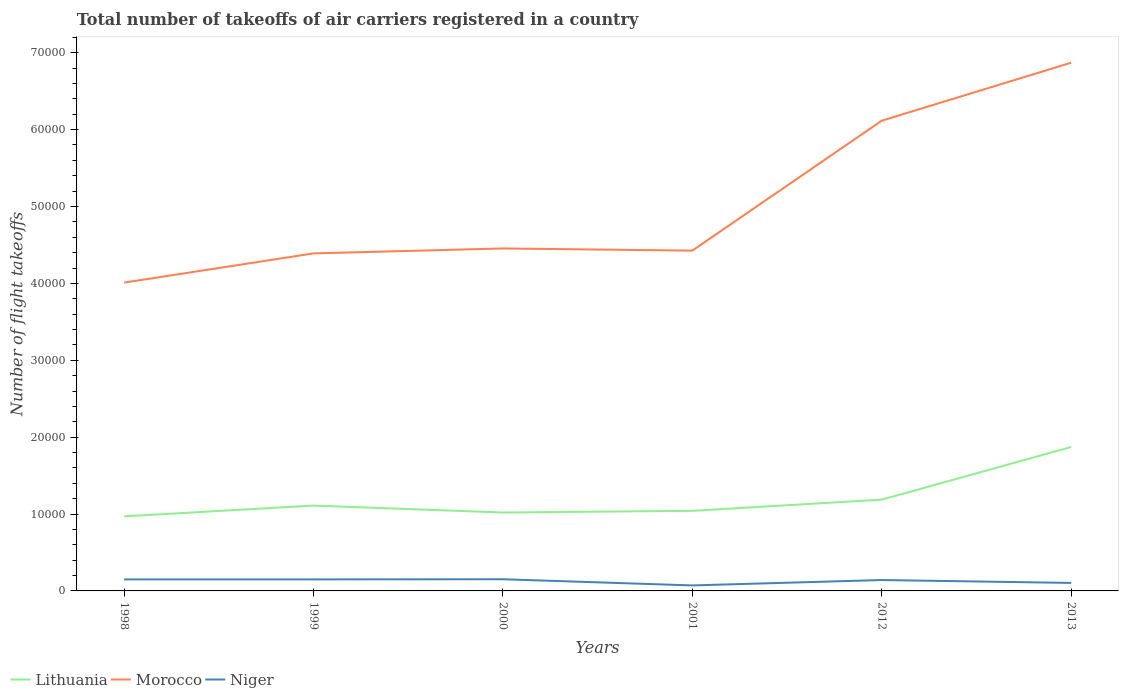How many different coloured lines are there?
Ensure brevity in your answer.  3. Does the line corresponding to Lithuania intersect with the line corresponding to Niger?
Provide a short and direct response. No. Is the number of lines equal to the number of legend labels?
Your answer should be very brief. Yes. Across all years, what is the maximum total number of flight takeoffs in Morocco?
Offer a very short reply. 4.01e+04. What is the total total number of flight takeoffs in Lithuania in the graph?
Ensure brevity in your answer.  -6846.54. What is the difference between the highest and the second highest total number of flight takeoffs in Niger?
Ensure brevity in your answer.  802. How many lines are there?
Keep it short and to the point. 3. How many years are there in the graph?
Your answer should be very brief. 6. Does the graph contain any zero values?
Ensure brevity in your answer.  No. Does the graph contain grids?
Make the answer very short. No. Where does the legend appear in the graph?
Your answer should be compact. Bottom left. How many legend labels are there?
Ensure brevity in your answer.  3. What is the title of the graph?
Make the answer very short. Total number of takeoffs of air carriers registered in a country. Does "Sweden" appear as one of the legend labels in the graph?
Ensure brevity in your answer.  No. What is the label or title of the Y-axis?
Keep it short and to the point. Number of flight takeoffs. What is the Number of flight takeoffs of Lithuania in 1998?
Your answer should be very brief. 9700. What is the Number of flight takeoffs in Morocco in 1998?
Your answer should be very brief. 4.01e+04. What is the Number of flight takeoffs in Niger in 1998?
Make the answer very short. 1500. What is the Number of flight takeoffs in Lithuania in 1999?
Offer a very short reply. 1.11e+04. What is the Number of flight takeoffs of Morocco in 1999?
Your response must be concise. 4.39e+04. What is the Number of flight takeoffs of Niger in 1999?
Keep it short and to the point. 1500. What is the Number of flight takeoffs of Lithuania in 2000?
Keep it short and to the point. 1.02e+04. What is the Number of flight takeoffs in Morocco in 2000?
Your answer should be very brief. 4.45e+04. What is the Number of flight takeoffs in Niger in 2000?
Provide a short and direct response. 1518. What is the Number of flight takeoffs of Lithuania in 2001?
Provide a succinct answer. 1.04e+04. What is the Number of flight takeoffs of Morocco in 2001?
Ensure brevity in your answer.  4.43e+04. What is the Number of flight takeoffs of Niger in 2001?
Provide a succinct answer. 716. What is the Number of flight takeoffs in Lithuania in 2012?
Your response must be concise. 1.19e+04. What is the Number of flight takeoffs in Morocco in 2012?
Ensure brevity in your answer.  6.12e+04. What is the Number of flight takeoffs in Niger in 2012?
Keep it short and to the point. 1416. What is the Number of flight takeoffs of Lithuania in 2013?
Ensure brevity in your answer.  1.87e+04. What is the Number of flight takeoffs of Morocco in 2013?
Your answer should be compact. 6.87e+04. What is the Number of flight takeoffs of Niger in 2013?
Give a very brief answer. 1040. Across all years, what is the maximum Number of flight takeoffs of Lithuania?
Offer a very short reply. 1.87e+04. Across all years, what is the maximum Number of flight takeoffs in Morocco?
Provide a succinct answer. 6.87e+04. Across all years, what is the maximum Number of flight takeoffs in Niger?
Give a very brief answer. 1518. Across all years, what is the minimum Number of flight takeoffs in Lithuania?
Offer a very short reply. 9700. Across all years, what is the minimum Number of flight takeoffs in Morocco?
Give a very brief answer. 4.01e+04. Across all years, what is the minimum Number of flight takeoffs of Niger?
Your answer should be very brief. 716. What is the total Number of flight takeoffs of Lithuania in the graph?
Your answer should be very brief. 7.20e+04. What is the total Number of flight takeoffs in Morocco in the graph?
Offer a terse response. 3.03e+05. What is the total Number of flight takeoffs in Niger in the graph?
Your response must be concise. 7690. What is the difference between the Number of flight takeoffs in Lithuania in 1998 and that in 1999?
Make the answer very short. -1400. What is the difference between the Number of flight takeoffs in Morocco in 1998 and that in 1999?
Your answer should be compact. -3800. What is the difference between the Number of flight takeoffs of Niger in 1998 and that in 1999?
Keep it short and to the point. 0. What is the difference between the Number of flight takeoffs in Lithuania in 1998 and that in 2000?
Give a very brief answer. -497. What is the difference between the Number of flight takeoffs in Morocco in 1998 and that in 2000?
Give a very brief answer. -4442. What is the difference between the Number of flight takeoffs in Lithuania in 1998 and that in 2001?
Offer a very short reply. -718. What is the difference between the Number of flight takeoffs in Morocco in 1998 and that in 2001?
Provide a short and direct response. -4162. What is the difference between the Number of flight takeoffs in Niger in 1998 and that in 2001?
Make the answer very short. 784. What is the difference between the Number of flight takeoffs in Lithuania in 1998 and that in 2012?
Provide a short and direct response. -2174. What is the difference between the Number of flight takeoffs in Morocco in 1998 and that in 2012?
Make the answer very short. -2.11e+04. What is the difference between the Number of flight takeoffs of Lithuania in 1998 and that in 2013?
Provide a succinct answer. -9020.54. What is the difference between the Number of flight takeoffs of Morocco in 1998 and that in 2013?
Offer a very short reply. -2.86e+04. What is the difference between the Number of flight takeoffs of Niger in 1998 and that in 2013?
Your response must be concise. 460. What is the difference between the Number of flight takeoffs of Lithuania in 1999 and that in 2000?
Ensure brevity in your answer.  903. What is the difference between the Number of flight takeoffs of Morocco in 1999 and that in 2000?
Ensure brevity in your answer.  -642. What is the difference between the Number of flight takeoffs of Niger in 1999 and that in 2000?
Your answer should be very brief. -18. What is the difference between the Number of flight takeoffs of Lithuania in 1999 and that in 2001?
Provide a succinct answer. 682. What is the difference between the Number of flight takeoffs of Morocco in 1999 and that in 2001?
Offer a very short reply. -362. What is the difference between the Number of flight takeoffs in Niger in 1999 and that in 2001?
Your answer should be very brief. 784. What is the difference between the Number of flight takeoffs in Lithuania in 1999 and that in 2012?
Provide a short and direct response. -774. What is the difference between the Number of flight takeoffs of Morocco in 1999 and that in 2012?
Offer a terse response. -1.73e+04. What is the difference between the Number of flight takeoffs in Lithuania in 1999 and that in 2013?
Your answer should be very brief. -7620.54. What is the difference between the Number of flight takeoffs in Morocco in 1999 and that in 2013?
Keep it short and to the point. -2.48e+04. What is the difference between the Number of flight takeoffs in Niger in 1999 and that in 2013?
Offer a terse response. 460. What is the difference between the Number of flight takeoffs in Lithuania in 2000 and that in 2001?
Offer a terse response. -221. What is the difference between the Number of flight takeoffs in Morocco in 2000 and that in 2001?
Provide a succinct answer. 280. What is the difference between the Number of flight takeoffs in Niger in 2000 and that in 2001?
Ensure brevity in your answer.  802. What is the difference between the Number of flight takeoffs of Lithuania in 2000 and that in 2012?
Offer a very short reply. -1677. What is the difference between the Number of flight takeoffs in Morocco in 2000 and that in 2012?
Offer a terse response. -1.66e+04. What is the difference between the Number of flight takeoffs of Niger in 2000 and that in 2012?
Provide a short and direct response. 102. What is the difference between the Number of flight takeoffs in Lithuania in 2000 and that in 2013?
Ensure brevity in your answer.  -8523.54. What is the difference between the Number of flight takeoffs of Morocco in 2000 and that in 2013?
Make the answer very short. -2.42e+04. What is the difference between the Number of flight takeoffs of Niger in 2000 and that in 2013?
Keep it short and to the point. 478. What is the difference between the Number of flight takeoffs in Lithuania in 2001 and that in 2012?
Ensure brevity in your answer.  -1456. What is the difference between the Number of flight takeoffs in Morocco in 2001 and that in 2012?
Offer a terse response. -1.69e+04. What is the difference between the Number of flight takeoffs in Niger in 2001 and that in 2012?
Keep it short and to the point. -700. What is the difference between the Number of flight takeoffs in Lithuania in 2001 and that in 2013?
Provide a short and direct response. -8302.54. What is the difference between the Number of flight takeoffs of Morocco in 2001 and that in 2013?
Give a very brief answer. -2.44e+04. What is the difference between the Number of flight takeoffs of Niger in 2001 and that in 2013?
Keep it short and to the point. -324. What is the difference between the Number of flight takeoffs in Lithuania in 2012 and that in 2013?
Your response must be concise. -6846.54. What is the difference between the Number of flight takeoffs in Morocco in 2012 and that in 2013?
Give a very brief answer. -7539.9. What is the difference between the Number of flight takeoffs of Niger in 2012 and that in 2013?
Provide a succinct answer. 376. What is the difference between the Number of flight takeoffs of Lithuania in 1998 and the Number of flight takeoffs of Morocco in 1999?
Keep it short and to the point. -3.42e+04. What is the difference between the Number of flight takeoffs of Lithuania in 1998 and the Number of flight takeoffs of Niger in 1999?
Offer a terse response. 8200. What is the difference between the Number of flight takeoffs in Morocco in 1998 and the Number of flight takeoffs in Niger in 1999?
Ensure brevity in your answer.  3.86e+04. What is the difference between the Number of flight takeoffs of Lithuania in 1998 and the Number of flight takeoffs of Morocco in 2000?
Make the answer very short. -3.48e+04. What is the difference between the Number of flight takeoffs in Lithuania in 1998 and the Number of flight takeoffs in Niger in 2000?
Keep it short and to the point. 8182. What is the difference between the Number of flight takeoffs in Morocco in 1998 and the Number of flight takeoffs in Niger in 2000?
Provide a short and direct response. 3.86e+04. What is the difference between the Number of flight takeoffs of Lithuania in 1998 and the Number of flight takeoffs of Morocco in 2001?
Give a very brief answer. -3.46e+04. What is the difference between the Number of flight takeoffs of Lithuania in 1998 and the Number of flight takeoffs of Niger in 2001?
Ensure brevity in your answer.  8984. What is the difference between the Number of flight takeoffs of Morocco in 1998 and the Number of flight takeoffs of Niger in 2001?
Ensure brevity in your answer.  3.94e+04. What is the difference between the Number of flight takeoffs in Lithuania in 1998 and the Number of flight takeoffs in Morocco in 2012?
Your response must be concise. -5.15e+04. What is the difference between the Number of flight takeoffs in Lithuania in 1998 and the Number of flight takeoffs in Niger in 2012?
Offer a terse response. 8284. What is the difference between the Number of flight takeoffs in Morocco in 1998 and the Number of flight takeoffs in Niger in 2012?
Your answer should be very brief. 3.87e+04. What is the difference between the Number of flight takeoffs of Lithuania in 1998 and the Number of flight takeoffs of Morocco in 2013?
Offer a terse response. -5.90e+04. What is the difference between the Number of flight takeoffs of Lithuania in 1998 and the Number of flight takeoffs of Niger in 2013?
Provide a succinct answer. 8660. What is the difference between the Number of flight takeoffs of Morocco in 1998 and the Number of flight takeoffs of Niger in 2013?
Provide a short and direct response. 3.91e+04. What is the difference between the Number of flight takeoffs of Lithuania in 1999 and the Number of flight takeoffs of Morocco in 2000?
Provide a succinct answer. -3.34e+04. What is the difference between the Number of flight takeoffs in Lithuania in 1999 and the Number of flight takeoffs in Niger in 2000?
Your answer should be compact. 9582. What is the difference between the Number of flight takeoffs of Morocco in 1999 and the Number of flight takeoffs of Niger in 2000?
Offer a terse response. 4.24e+04. What is the difference between the Number of flight takeoffs of Lithuania in 1999 and the Number of flight takeoffs of Morocco in 2001?
Provide a succinct answer. -3.32e+04. What is the difference between the Number of flight takeoffs in Lithuania in 1999 and the Number of flight takeoffs in Niger in 2001?
Your response must be concise. 1.04e+04. What is the difference between the Number of flight takeoffs of Morocco in 1999 and the Number of flight takeoffs of Niger in 2001?
Provide a succinct answer. 4.32e+04. What is the difference between the Number of flight takeoffs of Lithuania in 1999 and the Number of flight takeoffs of Morocco in 2012?
Ensure brevity in your answer.  -5.01e+04. What is the difference between the Number of flight takeoffs of Lithuania in 1999 and the Number of flight takeoffs of Niger in 2012?
Your answer should be very brief. 9684. What is the difference between the Number of flight takeoffs in Morocco in 1999 and the Number of flight takeoffs in Niger in 2012?
Keep it short and to the point. 4.25e+04. What is the difference between the Number of flight takeoffs of Lithuania in 1999 and the Number of flight takeoffs of Morocco in 2013?
Give a very brief answer. -5.76e+04. What is the difference between the Number of flight takeoffs in Lithuania in 1999 and the Number of flight takeoffs in Niger in 2013?
Provide a succinct answer. 1.01e+04. What is the difference between the Number of flight takeoffs in Morocco in 1999 and the Number of flight takeoffs in Niger in 2013?
Offer a terse response. 4.29e+04. What is the difference between the Number of flight takeoffs in Lithuania in 2000 and the Number of flight takeoffs in Morocco in 2001?
Your answer should be compact. -3.41e+04. What is the difference between the Number of flight takeoffs in Lithuania in 2000 and the Number of flight takeoffs in Niger in 2001?
Your answer should be compact. 9481. What is the difference between the Number of flight takeoffs of Morocco in 2000 and the Number of flight takeoffs of Niger in 2001?
Your answer should be very brief. 4.38e+04. What is the difference between the Number of flight takeoffs of Lithuania in 2000 and the Number of flight takeoffs of Morocco in 2012?
Provide a succinct answer. -5.10e+04. What is the difference between the Number of flight takeoffs in Lithuania in 2000 and the Number of flight takeoffs in Niger in 2012?
Make the answer very short. 8781. What is the difference between the Number of flight takeoffs of Morocco in 2000 and the Number of flight takeoffs of Niger in 2012?
Your response must be concise. 4.31e+04. What is the difference between the Number of flight takeoffs in Lithuania in 2000 and the Number of flight takeoffs in Morocco in 2013?
Provide a succinct answer. -5.85e+04. What is the difference between the Number of flight takeoffs of Lithuania in 2000 and the Number of flight takeoffs of Niger in 2013?
Keep it short and to the point. 9157. What is the difference between the Number of flight takeoffs of Morocco in 2000 and the Number of flight takeoffs of Niger in 2013?
Give a very brief answer. 4.35e+04. What is the difference between the Number of flight takeoffs in Lithuania in 2001 and the Number of flight takeoffs in Morocco in 2012?
Ensure brevity in your answer.  -5.07e+04. What is the difference between the Number of flight takeoffs in Lithuania in 2001 and the Number of flight takeoffs in Niger in 2012?
Make the answer very short. 9002. What is the difference between the Number of flight takeoffs of Morocco in 2001 and the Number of flight takeoffs of Niger in 2012?
Your response must be concise. 4.28e+04. What is the difference between the Number of flight takeoffs of Lithuania in 2001 and the Number of flight takeoffs of Morocco in 2013?
Offer a terse response. -5.83e+04. What is the difference between the Number of flight takeoffs in Lithuania in 2001 and the Number of flight takeoffs in Niger in 2013?
Make the answer very short. 9378. What is the difference between the Number of flight takeoffs in Morocco in 2001 and the Number of flight takeoffs in Niger in 2013?
Give a very brief answer. 4.32e+04. What is the difference between the Number of flight takeoffs in Lithuania in 2012 and the Number of flight takeoffs in Morocco in 2013?
Your answer should be very brief. -5.68e+04. What is the difference between the Number of flight takeoffs of Lithuania in 2012 and the Number of flight takeoffs of Niger in 2013?
Offer a very short reply. 1.08e+04. What is the difference between the Number of flight takeoffs of Morocco in 2012 and the Number of flight takeoffs of Niger in 2013?
Your answer should be very brief. 6.01e+04. What is the average Number of flight takeoffs in Lithuania per year?
Make the answer very short. 1.20e+04. What is the average Number of flight takeoffs of Morocco per year?
Ensure brevity in your answer.  5.04e+04. What is the average Number of flight takeoffs of Niger per year?
Provide a succinct answer. 1281.67. In the year 1998, what is the difference between the Number of flight takeoffs in Lithuania and Number of flight takeoffs in Morocco?
Ensure brevity in your answer.  -3.04e+04. In the year 1998, what is the difference between the Number of flight takeoffs of Lithuania and Number of flight takeoffs of Niger?
Offer a very short reply. 8200. In the year 1998, what is the difference between the Number of flight takeoffs of Morocco and Number of flight takeoffs of Niger?
Provide a short and direct response. 3.86e+04. In the year 1999, what is the difference between the Number of flight takeoffs of Lithuania and Number of flight takeoffs of Morocco?
Ensure brevity in your answer.  -3.28e+04. In the year 1999, what is the difference between the Number of flight takeoffs of Lithuania and Number of flight takeoffs of Niger?
Make the answer very short. 9600. In the year 1999, what is the difference between the Number of flight takeoffs of Morocco and Number of flight takeoffs of Niger?
Give a very brief answer. 4.24e+04. In the year 2000, what is the difference between the Number of flight takeoffs of Lithuania and Number of flight takeoffs of Morocco?
Ensure brevity in your answer.  -3.43e+04. In the year 2000, what is the difference between the Number of flight takeoffs in Lithuania and Number of flight takeoffs in Niger?
Your answer should be compact. 8679. In the year 2000, what is the difference between the Number of flight takeoffs in Morocco and Number of flight takeoffs in Niger?
Your answer should be very brief. 4.30e+04. In the year 2001, what is the difference between the Number of flight takeoffs in Lithuania and Number of flight takeoffs in Morocco?
Provide a short and direct response. -3.38e+04. In the year 2001, what is the difference between the Number of flight takeoffs in Lithuania and Number of flight takeoffs in Niger?
Offer a terse response. 9702. In the year 2001, what is the difference between the Number of flight takeoffs of Morocco and Number of flight takeoffs of Niger?
Keep it short and to the point. 4.35e+04. In the year 2012, what is the difference between the Number of flight takeoffs in Lithuania and Number of flight takeoffs in Morocco?
Make the answer very short. -4.93e+04. In the year 2012, what is the difference between the Number of flight takeoffs of Lithuania and Number of flight takeoffs of Niger?
Keep it short and to the point. 1.05e+04. In the year 2012, what is the difference between the Number of flight takeoffs of Morocco and Number of flight takeoffs of Niger?
Ensure brevity in your answer.  5.97e+04. In the year 2013, what is the difference between the Number of flight takeoffs in Lithuania and Number of flight takeoffs in Morocco?
Provide a succinct answer. -5.00e+04. In the year 2013, what is the difference between the Number of flight takeoffs of Lithuania and Number of flight takeoffs of Niger?
Keep it short and to the point. 1.77e+04. In the year 2013, what is the difference between the Number of flight takeoffs in Morocco and Number of flight takeoffs in Niger?
Your answer should be compact. 6.77e+04. What is the ratio of the Number of flight takeoffs in Lithuania in 1998 to that in 1999?
Offer a very short reply. 0.87. What is the ratio of the Number of flight takeoffs of Morocco in 1998 to that in 1999?
Make the answer very short. 0.91. What is the ratio of the Number of flight takeoffs in Niger in 1998 to that in 1999?
Offer a very short reply. 1. What is the ratio of the Number of flight takeoffs in Lithuania in 1998 to that in 2000?
Offer a very short reply. 0.95. What is the ratio of the Number of flight takeoffs in Morocco in 1998 to that in 2000?
Offer a very short reply. 0.9. What is the ratio of the Number of flight takeoffs of Lithuania in 1998 to that in 2001?
Your response must be concise. 0.93. What is the ratio of the Number of flight takeoffs of Morocco in 1998 to that in 2001?
Your response must be concise. 0.91. What is the ratio of the Number of flight takeoffs in Niger in 1998 to that in 2001?
Provide a succinct answer. 2.1. What is the ratio of the Number of flight takeoffs in Lithuania in 1998 to that in 2012?
Offer a terse response. 0.82. What is the ratio of the Number of flight takeoffs in Morocco in 1998 to that in 2012?
Ensure brevity in your answer.  0.66. What is the ratio of the Number of flight takeoffs in Niger in 1998 to that in 2012?
Your answer should be compact. 1.06. What is the ratio of the Number of flight takeoffs of Lithuania in 1998 to that in 2013?
Provide a short and direct response. 0.52. What is the ratio of the Number of flight takeoffs of Morocco in 1998 to that in 2013?
Give a very brief answer. 0.58. What is the ratio of the Number of flight takeoffs of Niger in 1998 to that in 2013?
Provide a short and direct response. 1.44. What is the ratio of the Number of flight takeoffs of Lithuania in 1999 to that in 2000?
Make the answer very short. 1.09. What is the ratio of the Number of flight takeoffs in Morocco in 1999 to that in 2000?
Provide a short and direct response. 0.99. What is the ratio of the Number of flight takeoffs in Niger in 1999 to that in 2000?
Provide a short and direct response. 0.99. What is the ratio of the Number of flight takeoffs of Lithuania in 1999 to that in 2001?
Provide a short and direct response. 1.07. What is the ratio of the Number of flight takeoffs of Morocco in 1999 to that in 2001?
Your answer should be compact. 0.99. What is the ratio of the Number of flight takeoffs of Niger in 1999 to that in 2001?
Offer a very short reply. 2.1. What is the ratio of the Number of flight takeoffs of Lithuania in 1999 to that in 2012?
Your answer should be compact. 0.93. What is the ratio of the Number of flight takeoffs in Morocco in 1999 to that in 2012?
Your answer should be very brief. 0.72. What is the ratio of the Number of flight takeoffs in Niger in 1999 to that in 2012?
Ensure brevity in your answer.  1.06. What is the ratio of the Number of flight takeoffs in Lithuania in 1999 to that in 2013?
Give a very brief answer. 0.59. What is the ratio of the Number of flight takeoffs in Morocco in 1999 to that in 2013?
Make the answer very short. 0.64. What is the ratio of the Number of flight takeoffs in Niger in 1999 to that in 2013?
Ensure brevity in your answer.  1.44. What is the ratio of the Number of flight takeoffs of Lithuania in 2000 to that in 2001?
Provide a succinct answer. 0.98. What is the ratio of the Number of flight takeoffs of Morocco in 2000 to that in 2001?
Offer a very short reply. 1.01. What is the ratio of the Number of flight takeoffs in Niger in 2000 to that in 2001?
Make the answer very short. 2.12. What is the ratio of the Number of flight takeoffs of Lithuania in 2000 to that in 2012?
Your answer should be very brief. 0.86. What is the ratio of the Number of flight takeoffs of Morocco in 2000 to that in 2012?
Your answer should be compact. 0.73. What is the ratio of the Number of flight takeoffs in Niger in 2000 to that in 2012?
Your response must be concise. 1.07. What is the ratio of the Number of flight takeoffs in Lithuania in 2000 to that in 2013?
Offer a terse response. 0.54. What is the ratio of the Number of flight takeoffs in Morocco in 2000 to that in 2013?
Your answer should be very brief. 0.65. What is the ratio of the Number of flight takeoffs in Niger in 2000 to that in 2013?
Give a very brief answer. 1.46. What is the ratio of the Number of flight takeoffs of Lithuania in 2001 to that in 2012?
Give a very brief answer. 0.88. What is the ratio of the Number of flight takeoffs in Morocco in 2001 to that in 2012?
Provide a succinct answer. 0.72. What is the ratio of the Number of flight takeoffs in Niger in 2001 to that in 2012?
Your answer should be compact. 0.51. What is the ratio of the Number of flight takeoffs of Lithuania in 2001 to that in 2013?
Provide a short and direct response. 0.56. What is the ratio of the Number of flight takeoffs in Morocco in 2001 to that in 2013?
Provide a succinct answer. 0.64. What is the ratio of the Number of flight takeoffs of Niger in 2001 to that in 2013?
Ensure brevity in your answer.  0.69. What is the ratio of the Number of flight takeoffs of Lithuania in 2012 to that in 2013?
Offer a terse response. 0.63. What is the ratio of the Number of flight takeoffs in Morocco in 2012 to that in 2013?
Provide a short and direct response. 0.89. What is the ratio of the Number of flight takeoffs of Niger in 2012 to that in 2013?
Offer a terse response. 1.36. What is the difference between the highest and the second highest Number of flight takeoffs of Lithuania?
Your answer should be compact. 6846.54. What is the difference between the highest and the second highest Number of flight takeoffs in Morocco?
Provide a short and direct response. 7539.9. What is the difference between the highest and the second highest Number of flight takeoffs of Niger?
Your response must be concise. 18. What is the difference between the highest and the lowest Number of flight takeoffs in Lithuania?
Ensure brevity in your answer.  9020.54. What is the difference between the highest and the lowest Number of flight takeoffs of Morocco?
Offer a terse response. 2.86e+04. What is the difference between the highest and the lowest Number of flight takeoffs of Niger?
Ensure brevity in your answer.  802. 